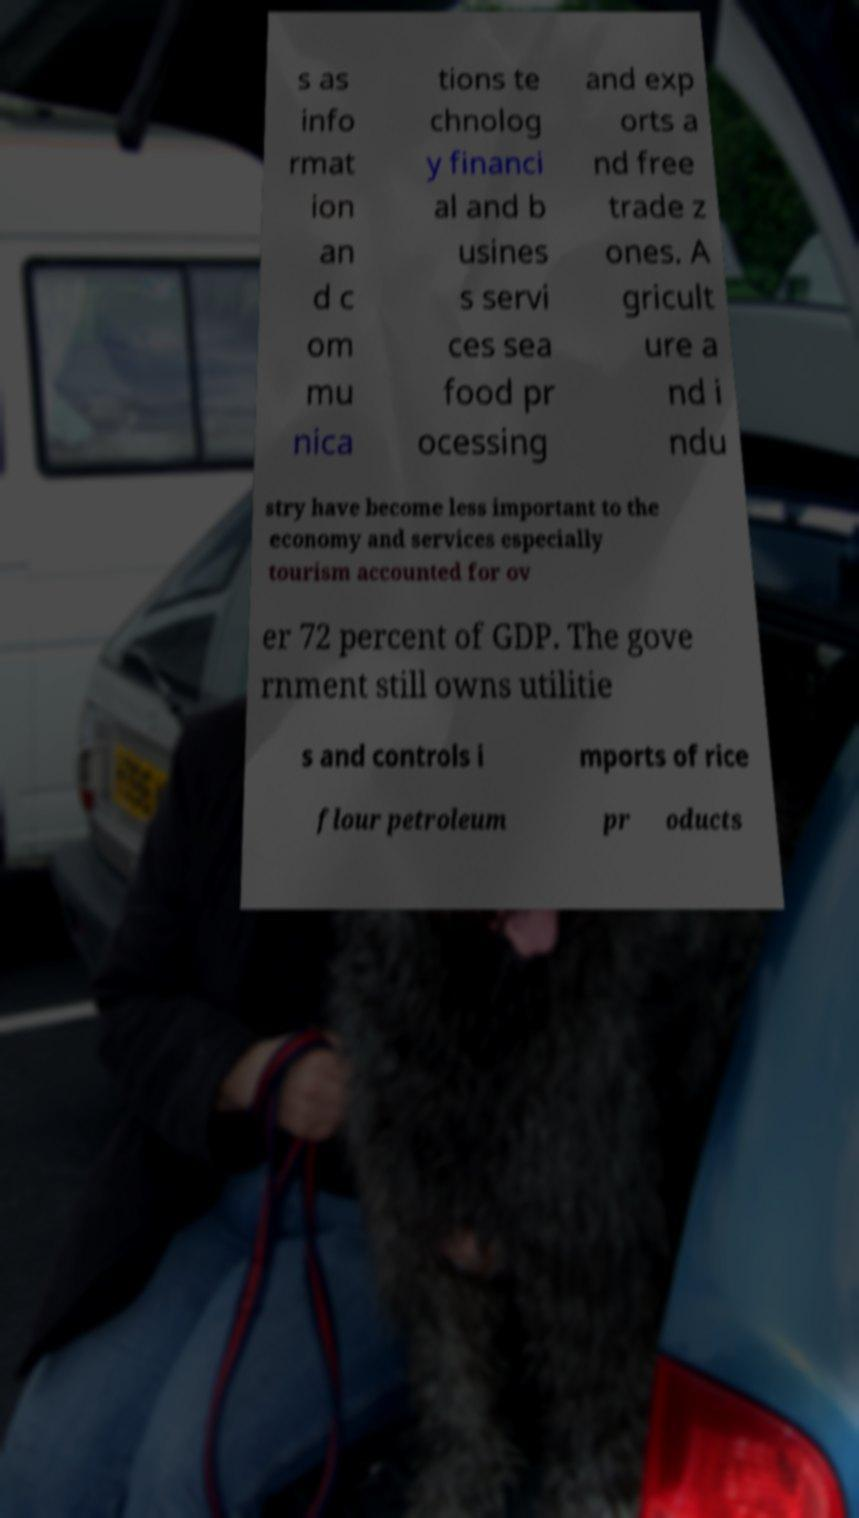I need the written content from this picture converted into text. Can you do that? s as info rmat ion an d c om mu nica tions te chnolog y financi al and b usines s servi ces sea food pr ocessing and exp orts a nd free trade z ones. A gricult ure a nd i ndu stry have become less important to the economy and services especially tourism accounted for ov er 72 percent of GDP. The gove rnment still owns utilitie s and controls i mports of rice flour petroleum pr oducts 